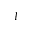Convert formula to latex. <formula><loc_0><loc_0><loc_500><loc_500>I</formula> 